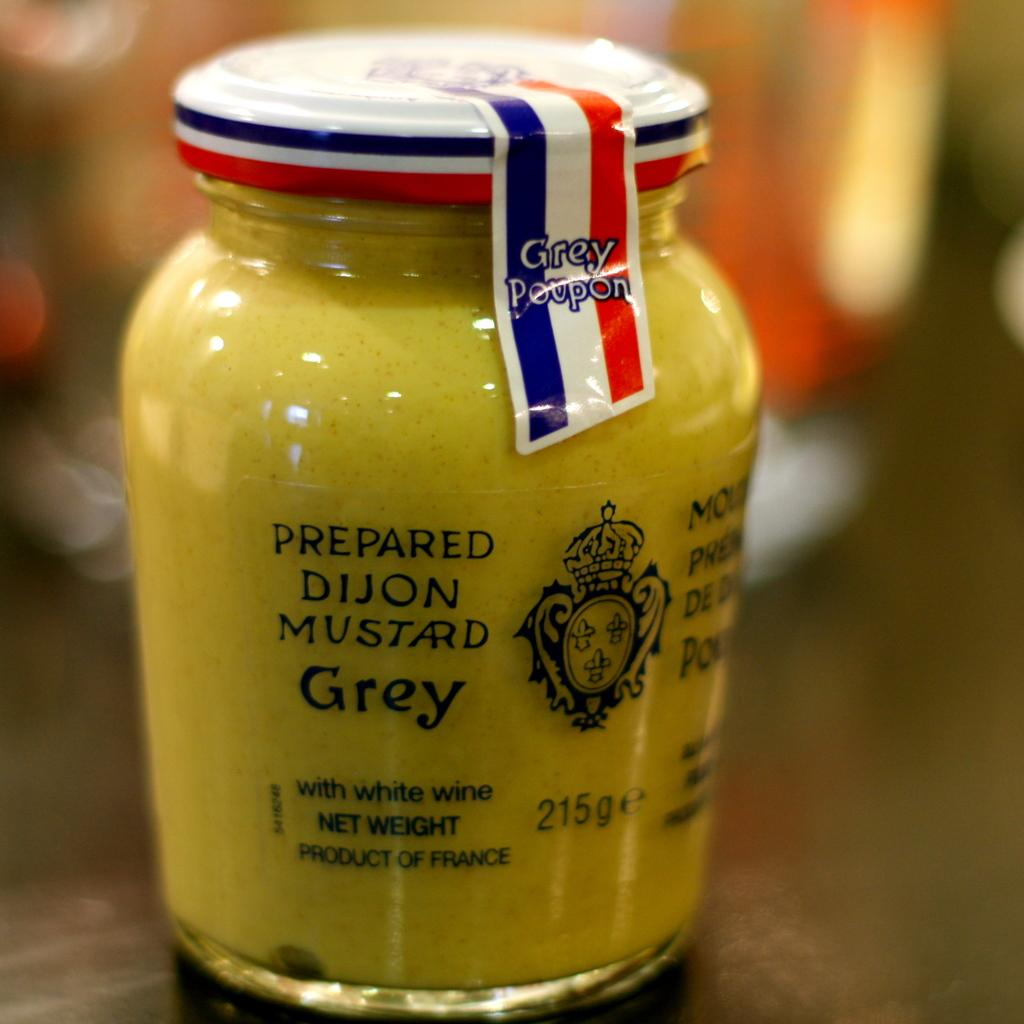<image>
Render a clear and concise summary of the photo. A jar of Dijon mustard on a table. 